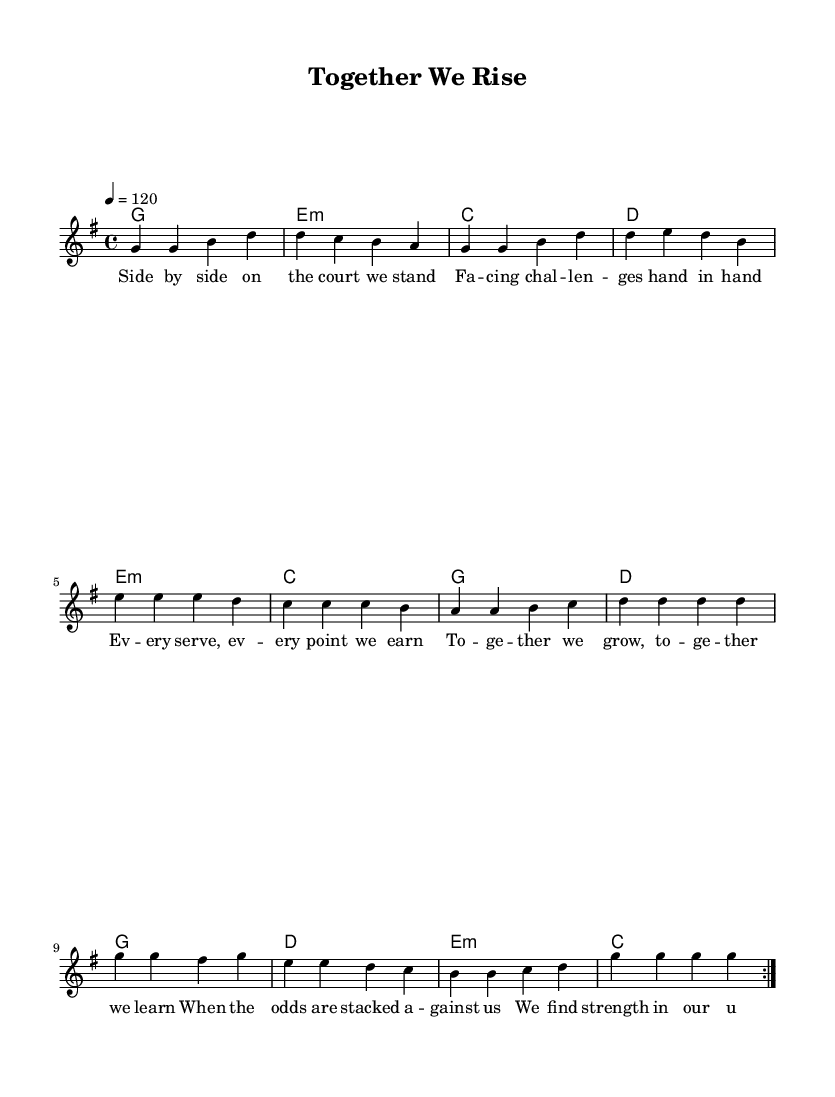What is the key signature of this music? The key signature is G major, which has one sharp (F#). This can be identified by looking at the key signature indicated at the beginning of the staff.
Answer: G major What is the time signature of this music? The time signature is 4/4, which is shown at the beginning of the score. It means there are four beats in each measure and the quarter note gets one beat.
Answer: 4/4 What is the tempo marking of this piece? The tempo marking is 120 beats per minute, indicated by "4 = 120" at the beginning of the score. This specifies how fast the music should be played.
Answer: 120 How many measures are in the repeated section of the melody? There are 8 measures in the repeated section of the melody. This is determined by counting the measures in the repeated section from the start to the end of the volta.
Answer: 8 What is the primary chord used in the harmonies? The primary chord used in the harmonies is G major. This can be confirmed by checking the chord names listed in the harmonic changes beneath the melody, where G major is the first chord in every repeated section.
Answer: G What is the lyrical theme of the song? The lyrical theme of the song revolves around unity and overcoming challenges together. This is derived from repeated phrases in the lyrics such as "together we rise" and "find strength in our unity."
Answer: Unity and overcoming challenges How many times is the melody section repeated? The melody section is repeated 2 times, as indicated by the "repeat volta 2" directive in the score. This means the section will be played twice through.
Answer: 2 